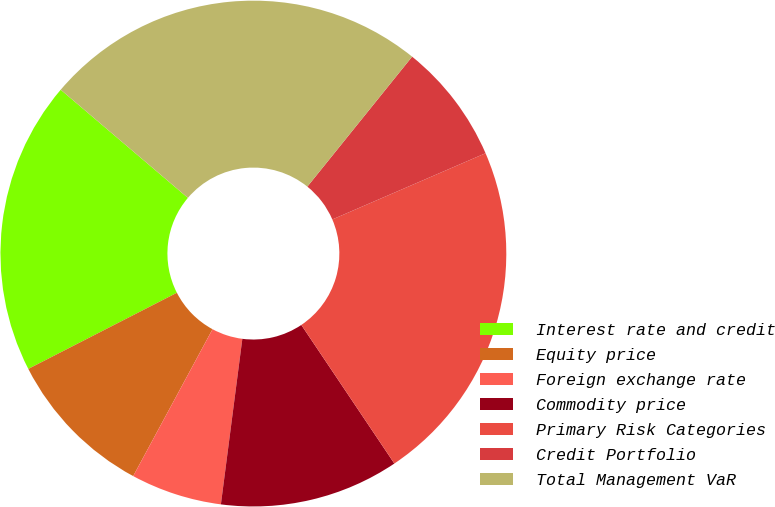<chart> <loc_0><loc_0><loc_500><loc_500><pie_chart><fcel>Interest rate and credit<fcel>Equity price<fcel>Foreign exchange rate<fcel>Commodity price<fcel>Primary Risk Categories<fcel>Credit Portfolio<fcel>Total Management VaR<nl><fcel>18.75%<fcel>9.58%<fcel>5.83%<fcel>11.46%<fcel>22.08%<fcel>7.71%<fcel>24.58%<nl></chart> 